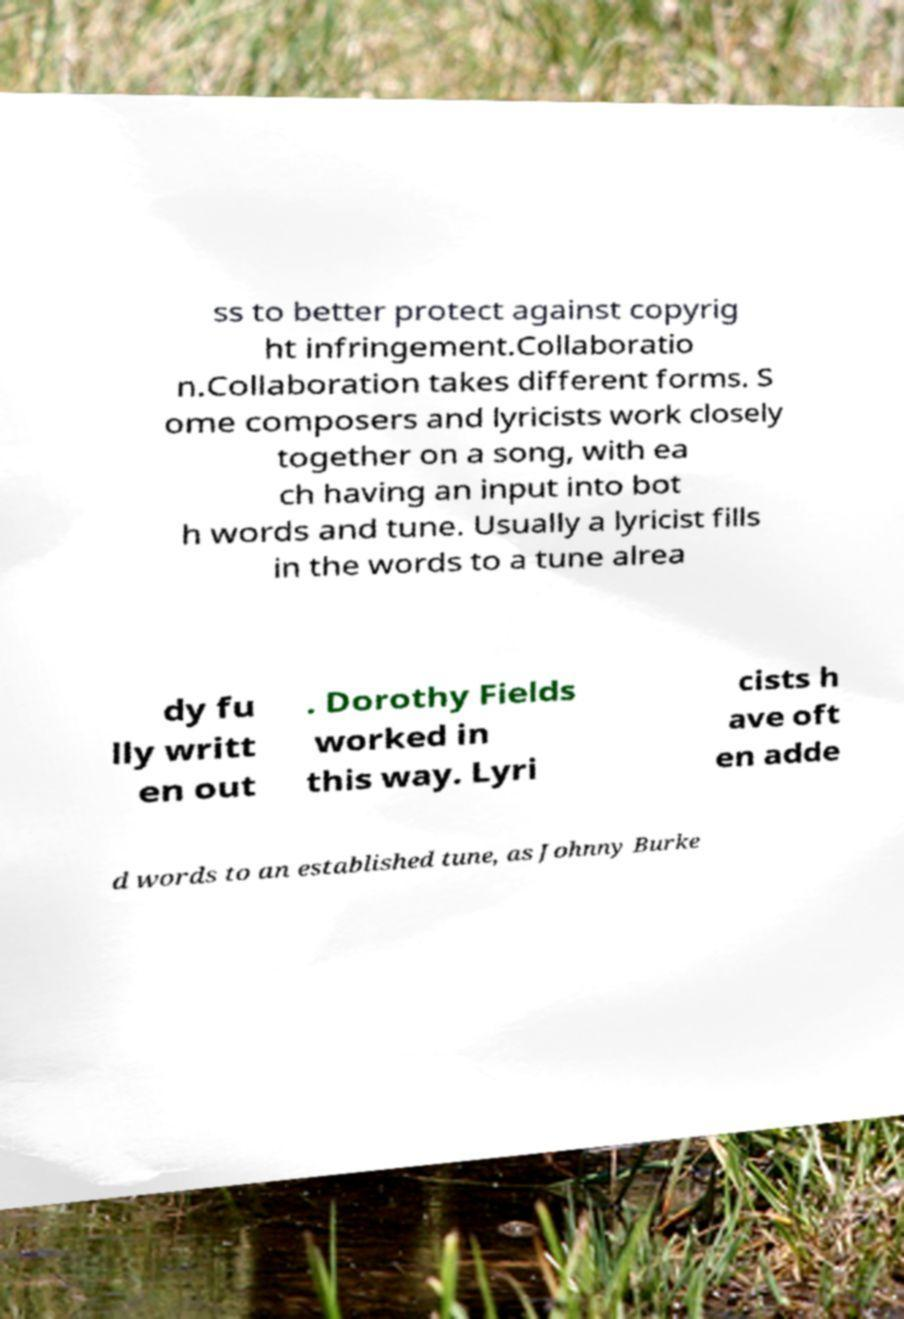Can you accurately transcribe the text from the provided image for me? ss to better protect against copyrig ht infringement.Collaboratio n.Collaboration takes different forms. S ome composers and lyricists work closely together on a song, with ea ch having an input into bot h words and tune. Usually a lyricist fills in the words to a tune alrea dy fu lly writt en out . Dorothy Fields worked in this way. Lyri cists h ave oft en adde d words to an established tune, as Johnny Burke 